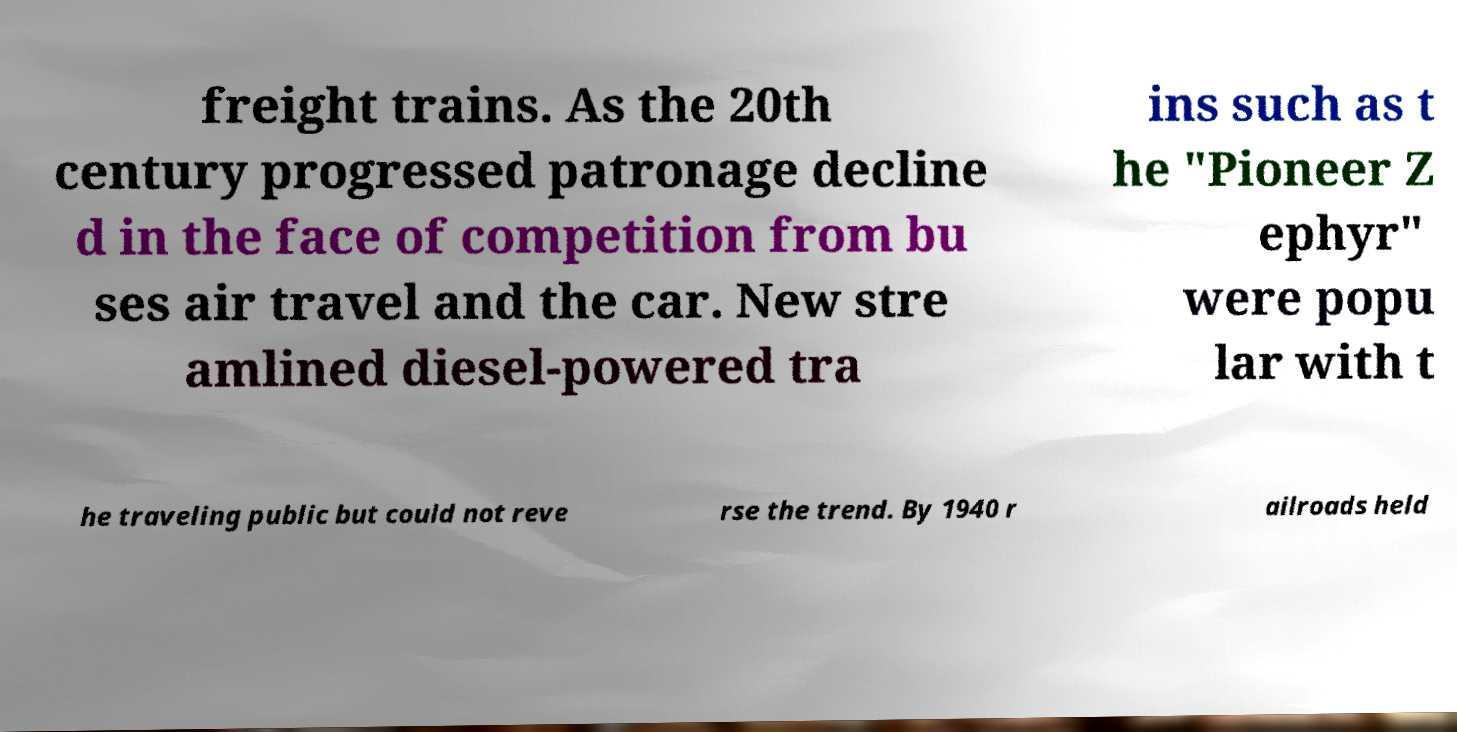Please identify and transcribe the text found in this image. freight trains. As the 20th century progressed patronage decline d in the face of competition from bu ses air travel and the car. New stre amlined diesel-powered tra ins such as t he "Pioneer Z ephyr" were popu lar with t he traveling public but could not reve rse the trend. By 1940 r ailroads held 